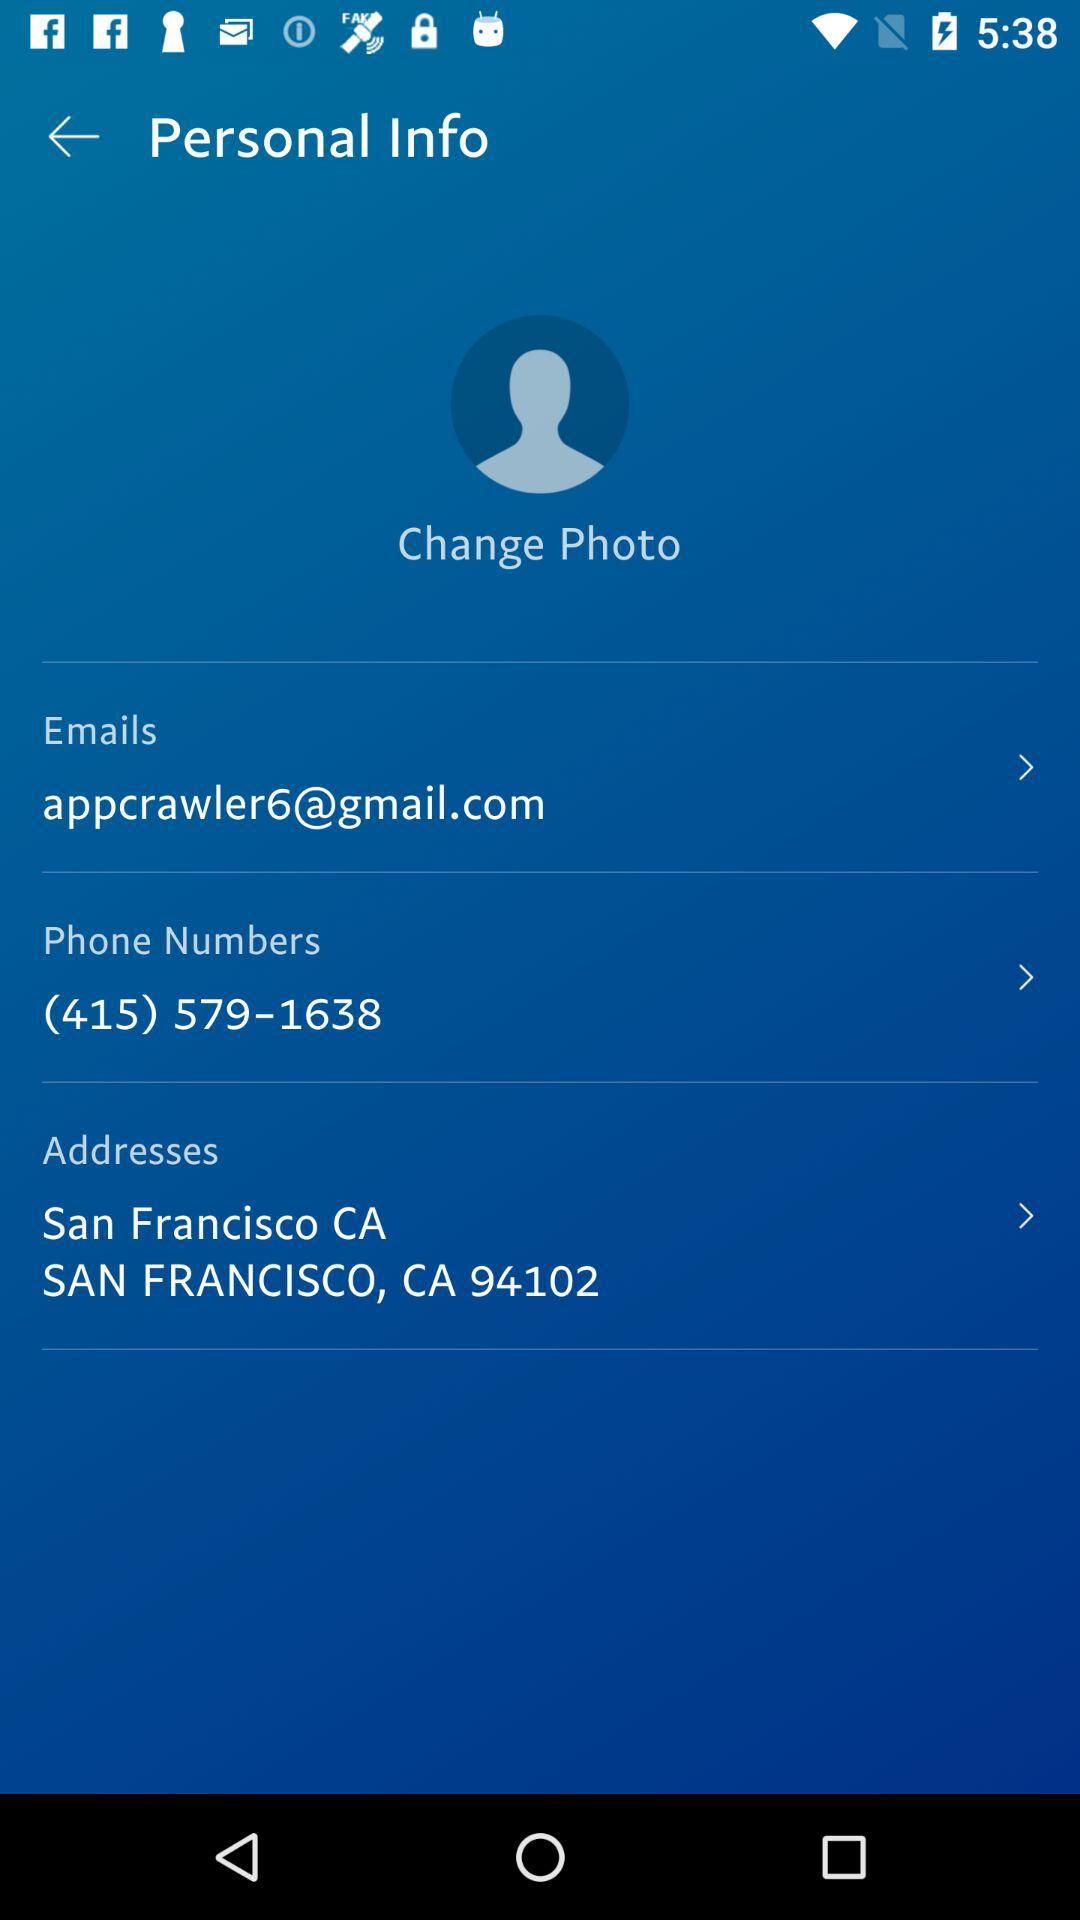What is the email address mentioned there? The mentioned email address is appcrawler6@gmail.com. 